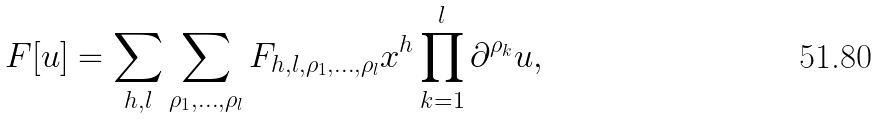<formula> <loc_0><loc_0><loc_500><loc_500>F [ u ] = \sum _ { h , l } \sum _ { \rho _ { 1 } , \dots , \rho _ { l } } F _ { h , l , \rho _ { 1 } , \dots , \rho _ { l } } x ^ { h } \prod _ { k = 1 } ^ { l } \partial ^ { \rho _ { k } } u ,</formula> 